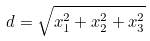<formula> <loc_0><loc_0><loc_500><loc_500>d = \sqrt { x _ { 1 } ^ { 2 } + x _ { 2 } ^ { 2 } + x _ { 3 } ^ { 2 } }</formula> 